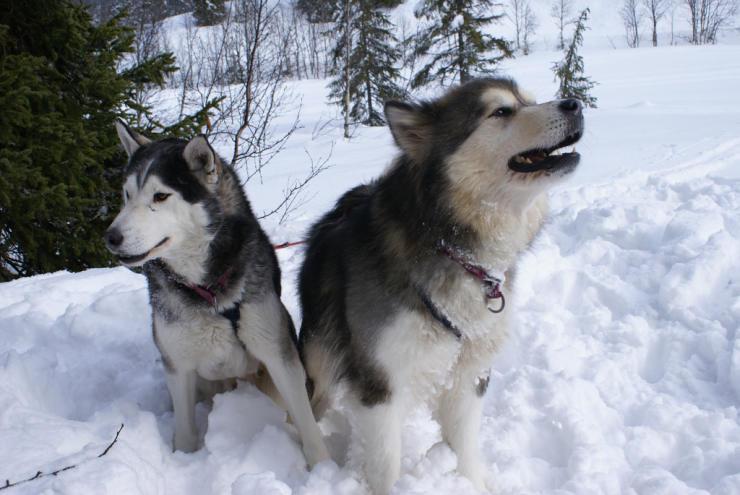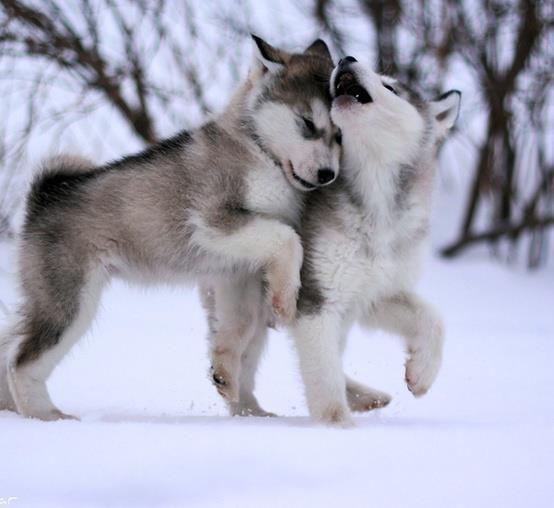The first image is the image on the left, the second image is the image on the right. Evaluate the accuracy of this statement regarding the images: "There are four animals.". Is it true? Answer yes or no. Yes. The first image is the image on the left, the second image is the image on the right. For the images displayed, is the sentence "At least one of the images shows a dog interacting with a mammal that is not a dog." factually correct? Answer yes or no. No. 